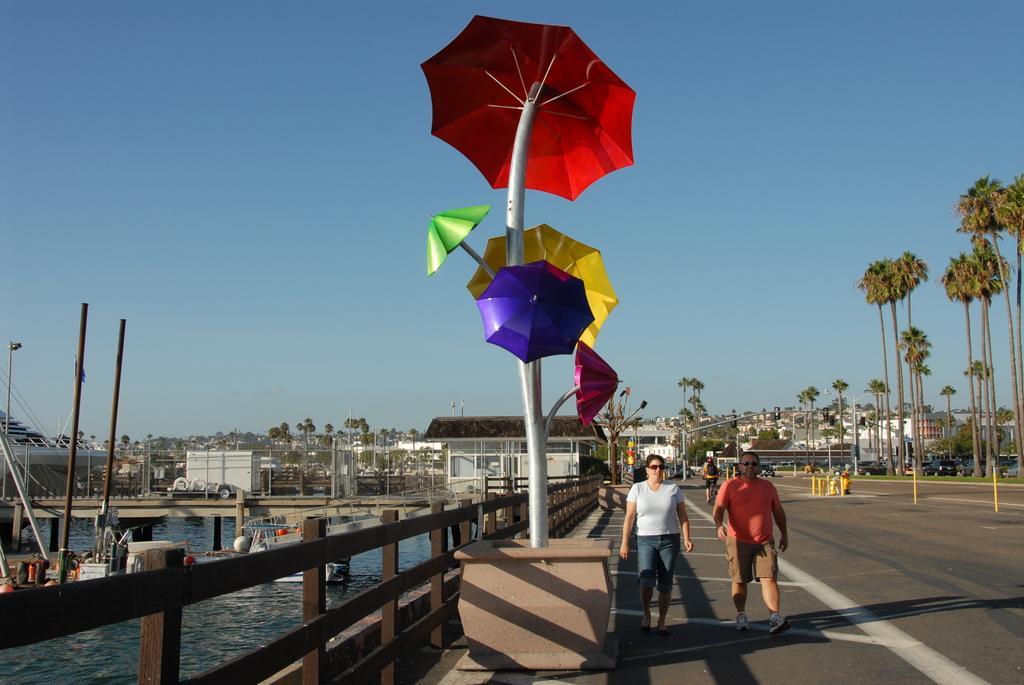Describe this image in one or two sentences. In the center of the image we can see a pole, umbrellas. In the background of the image we can see the trees, buildings, barricades, house, bridge, poles, railing. On the left side of the image we can see the water, boats and vehicle. On the right side of the image we can see two people are walking on the road. At the top of the image we can see the sky. 